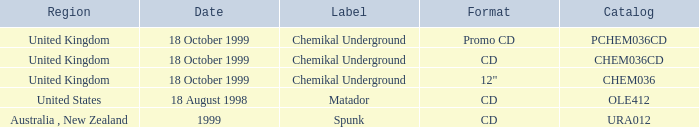What label has a catalog of chem036cd? Chemikal Underground. 